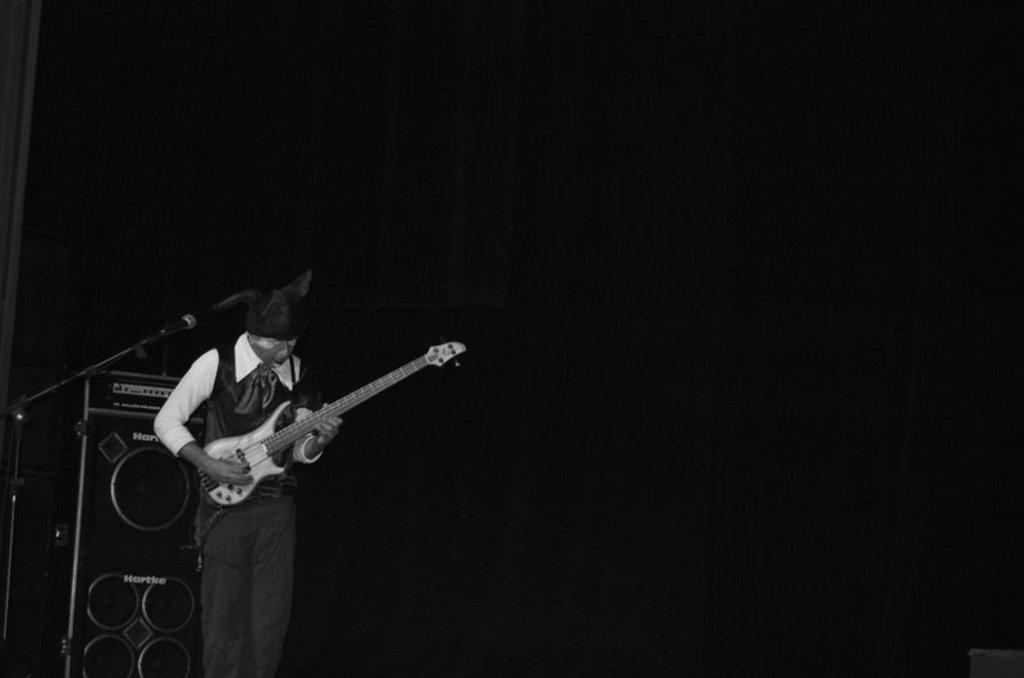How would you summarize this image in a sentence or two? In this image I can see a person standing in-front of the mic and playing the guitar. In the background there is a sound system. 